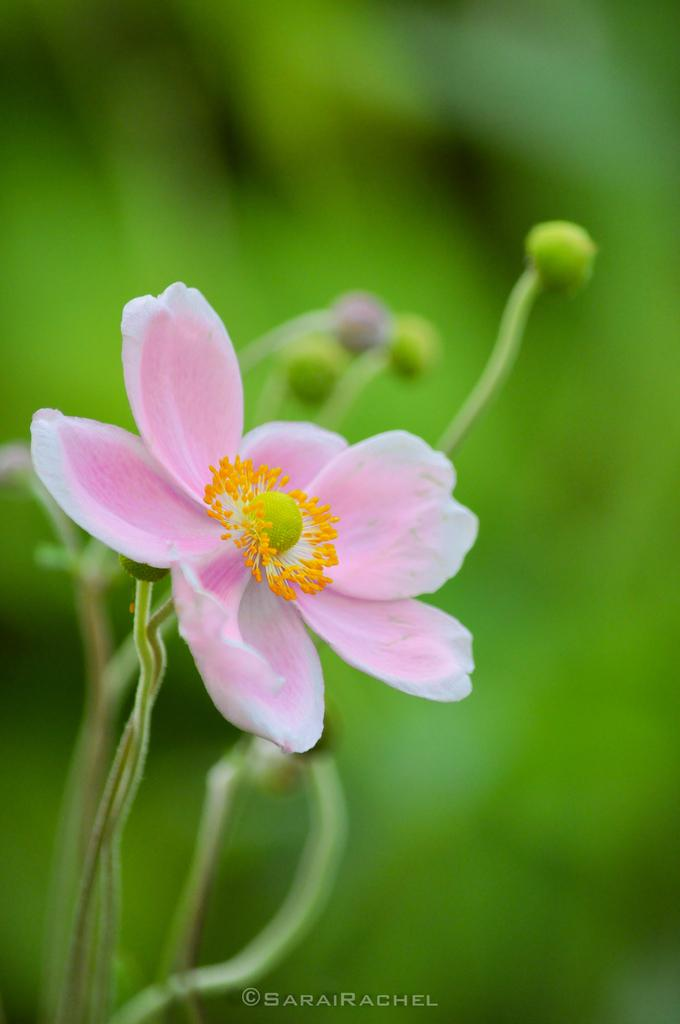What is the main subject of the image? There is a flower in the image. Can you describe the colors of the flower? The flower has pink, yellow, and green colors. What is the flower attached to? The flower is attached to a green plant. How would you describe the background of the image? The background of the image is green and blurry. What type of meat can be seen hanging from the flower in the image? There is no meat present in the image; it features a flower with pink, yellow, and green colors attached to a green plant. 